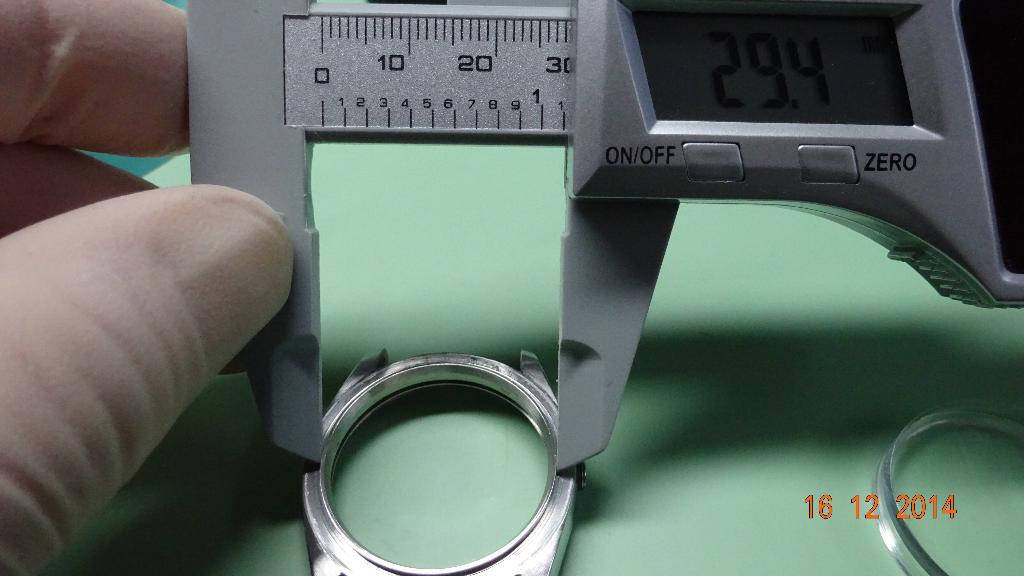What year was this photo taken?
Keep it short and to the point. 2014. 